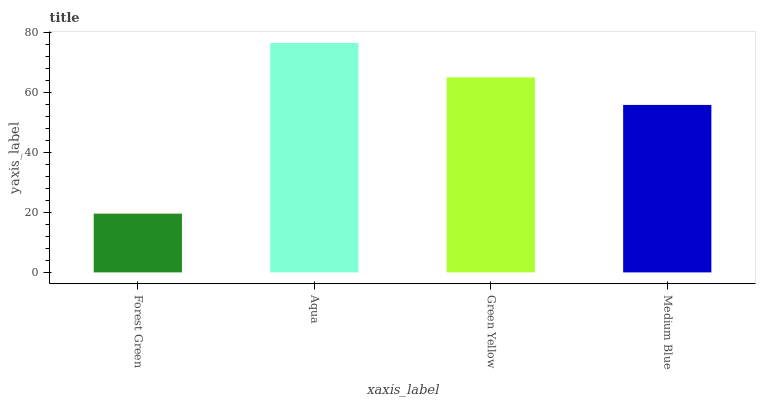Is Forest Green the minimum?
Answer yes or no. Yes. Is Aqua the maximum?
Answer yes or no. Yes. Is Green Yellow the minimum?
Answer yes or no. No. Is Green Yellow the maximum?
Answer yes or no. No. Is Aqua greater than Green Yellow?
Answer yes or no. Yes. Is Green Yellow less than Aqua?
Answer yes or no. Yes. Is Green Yellow greater than Aqua?
Answer yes or no. No. Is Aqua less than Green Yellow?
Answer yes or no. No. Is Green Yellow the high median?
Answer yes or no. Yes. Is Medium Blue the low median?
Answer yes or no. Yes. Is Forest Green the high median?
Answer yes or no. No. Is Forest Green the low median?
Answer yes or no. No. 